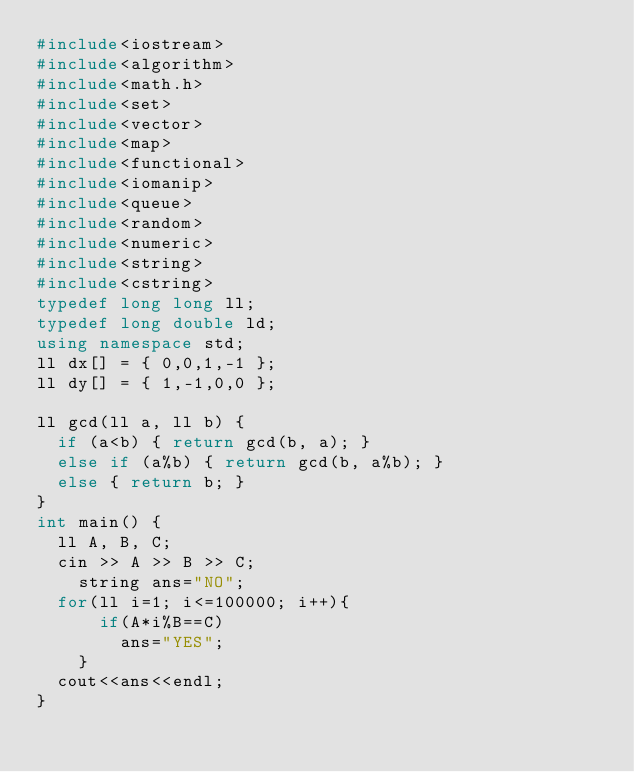<code> <loc_0><loc_0><loc_500><loc_500><_C++_>#include<iostream>
#include<algorithm>
#include<math.h>
#include<set>
#include<vector>
#include<map>
#include<functional>
#include<iomanip>
#include<queue>
#include<random>
#include<numeric>
#include<string>
#include<cstring>
typedef long long ll;
typedef long double ld;
using namespace std;
ll dx[] = { 0,0,1,-1 };
ll dy[] = { 1,-1,0,0 };

ll gcd(ll a, ll b) {
	if (a<b) { return gcd(b, a); }
	else if (a%b) { return gcd(b, a%b); }
	else { return b; }
}
int main() {
	ll A, B, C;
	cin >> A >> B >> C;
  	string ans="NO";
	for(ll i=1; i<=100000; i++){
      if(A*i%B==C)
        ans="YES";
    }
  cout<<ans<<endl;
}





</code> 